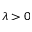Convert formula to latex. <formula><loc_0><loc_0><loc_500><loc_500>\lambda > 0</formula> 